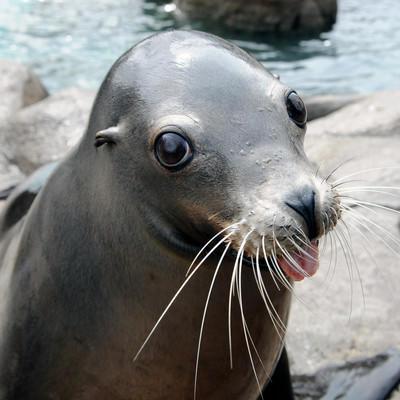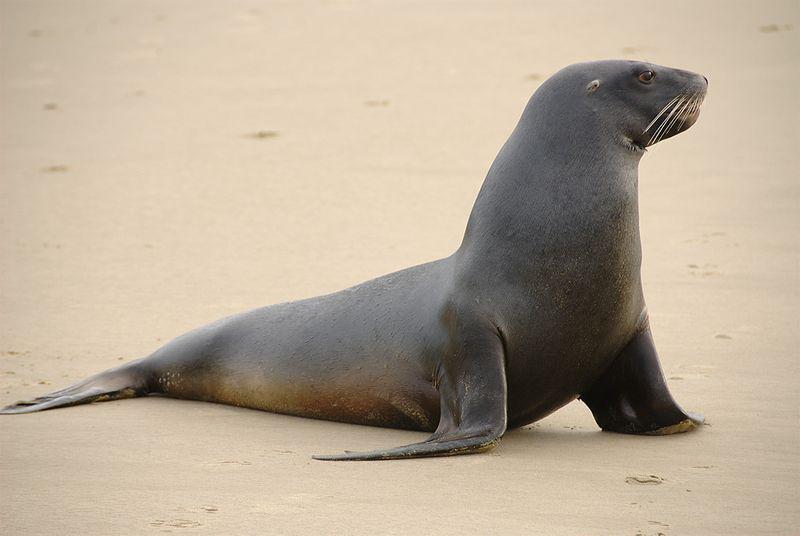The first image is the image on the left, the second image is the image on the right. Given the left and right images, does the statement "There is 1 seal near waves on a sunny day." hold true? Answer yes or no. No. The first image is the image on the left, the second image is the image on the right. Considering the images on both sides, is "An image shows a seal with body in profile and water visible." valid? Answer yes or no. No. 